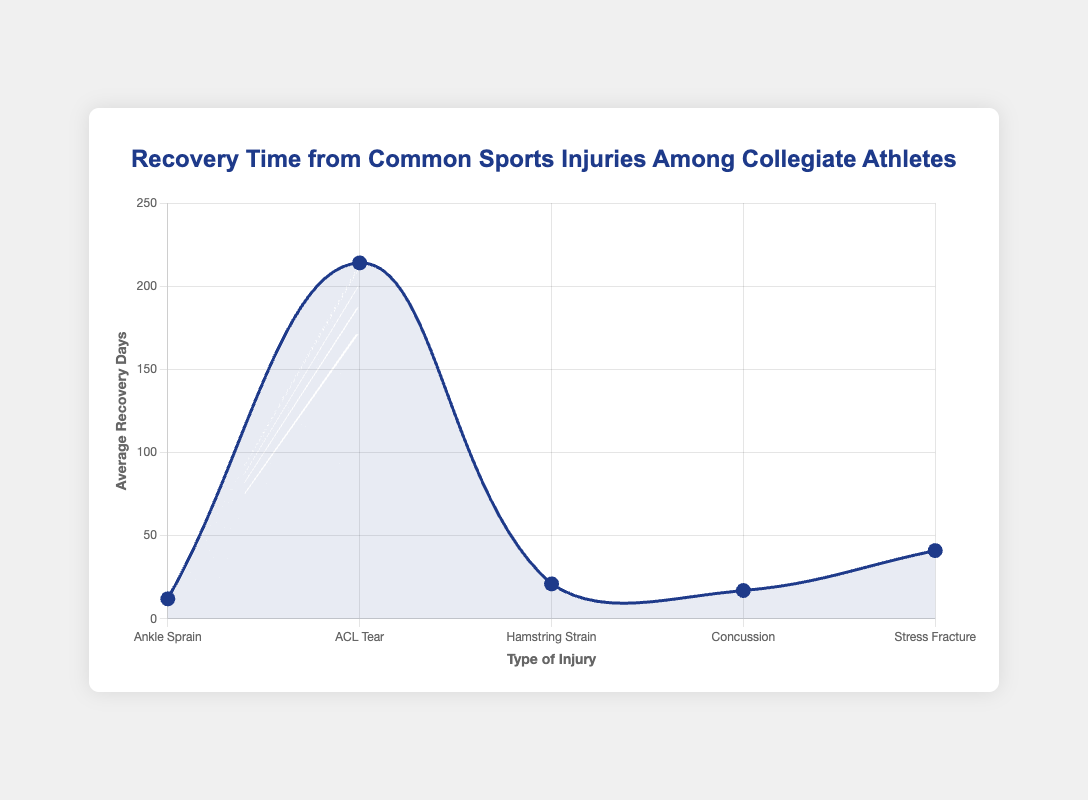What is the average recovery time for Ankle Sprain injuries? The average recovery time for Ankle Sprain injuries is calculated by summing the recovery days for all athletes with Ankle Sprain and dividing by the number of athletes. The sum of recovery days (14 + 10 + 12 + 11 + 15) is 62. Dividing by 5 athletes gives an average of 62/5 = 12.4 days.
Answer: 12.4 days Which injury type has the longest average recovery time? By comparing the average recovery times for each injury type, ACL Tear has the longest average recovery time with an average of 214 days. This is evident from the visual peak of the ACL Tear on the chart.
Answer: ACL Tear Is the average recovery time for Concussion longer than that for Hamstring Strain? The average recovery days for Concussion is 17.4 days, while for Hamstring Strain it is 21 days. Therefore, the average recovery time for Concussion is shorter than that for Hamstring Strain.
Answer: No What is the total average recovery time for Stress Fracture injuries? The total recovery days for Stress Fracture injuries is the sum of each athlete's recovery days: 42 + 40 + 45 + 38 + 41 = 206 days. Dividing by 5 athletes, the average is 206/5 = 41.2 days.
Answer: 41.2 days Compare the average recovery time for ACL Tear and Ankle Sprain injuries. Which one is higher and by how much? The average recovery time for ACL Tear is 214 days, and for Ankle Sprain, it is 12.4 days. The difference is 214 - 12.4 = 201.6 days. Therefore, ACL Tear has a higher average recovery time by 201.6 days.
Answer: ACL Tear by 201.6 days Which injury type has the shortest average recovery time in the chart? By assessing the visual information on the chart, Ankle Sprain has the shortest average recovery time, which is 12.4 days. This is the lowest point on the line graph.
Answer: Ankle Sprain What is the difference in average recovery days between Concussion and Stress Fracture injuries? The average recovery days for Concussion is 17.4, while for Stress Fracture it is 41.2 days. The difference is calculated as 41.2 - 17.4 = 23.8 days.
Answer: 23.8 days 